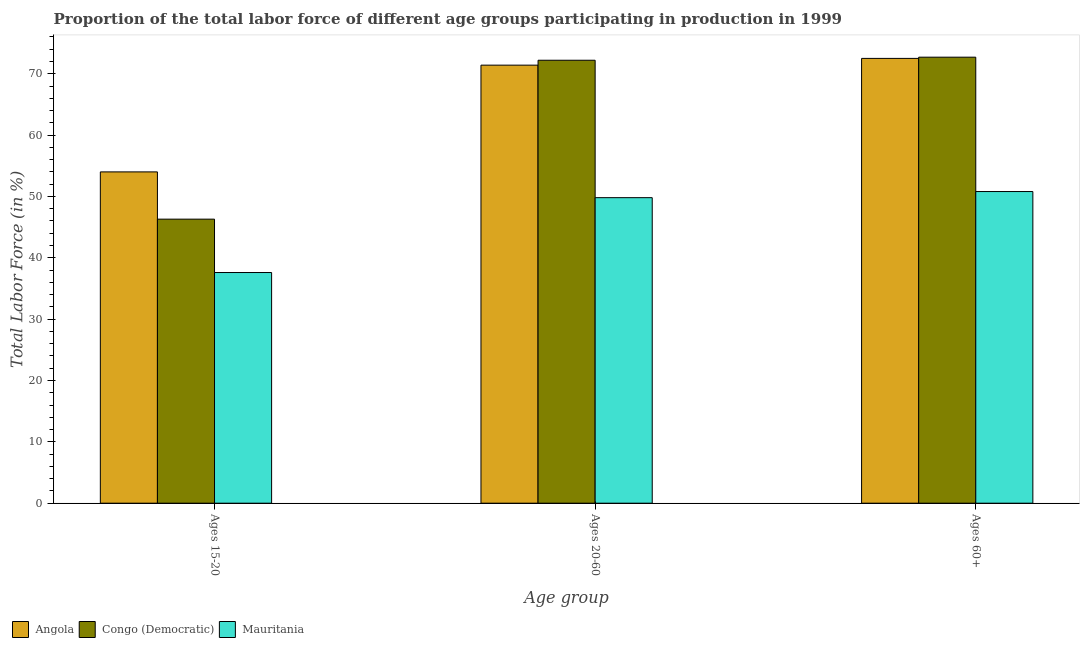How many groups of bars are there?
Ensure brevity in your answer.  3. What is the label of the 1st group of bars from the left?
Your answer should be very brief. Ages 15-20. What is the percentage of labor force within the age group 20-60 in Angola?
Offer a terse response. 71.4. Across all countries, what is the maximum percentage of labor force within the age group 20-60?
Your answer should be compact. 72.2. Across all countries, what is the minimum percentage of labor force within the age group 15-20?
Your answer should be compact. 37.6. In which country was the percentage of labor force within the age group 15-20 maximum?
Ensure brevity in your answer.  Angola. In which country was the percentage of labor force within the age group 15-20 minimum?
Keep it short and to the point. Mauritania. What is the total percentage of labor force above age 60 in the graph?
Your answer should be very brief. 196. What is the difference between the percentage of labor force within the age group 20-60 in Angola and that in Congo (Democratic)?
Make the answer very short. -0.8. What is the difference between the percentage of labor force above age 60 in Mauritania and the percentage of labor force within the age group 20-60 in Congo (Democratic)?
Ensure brevity in your answer.  -21.4. What is the average percentage of labor force within the age group 20-60 per country?
Your response must be concise. 64.47. What is the difference between the percentage of labor force within the age group 15-20 and percentage of labor force above age 60 in Angola?
Provide a succinct answer. -18.5. What is the ratio of the percentage of labor force within the age group 20-60 in Mauritania to that in Congo (Democratic)?
Provide a short and direct response. 0.69. Is the difference between the percentage of labor force within the age group 15-20 in Angola and Congo (Democratic) greater than the difference between the percentage of labor force above age 60 in Angola and Congo (Democratic)?
Offer a terse response. Yes. What is the difference between the highest and the second highest percentage of labor force within the age group 20-60?
Offer a very short reply. 0.8. What is the difference between the highest and the lowest percentage of labor force above age 60?
Provide a short and direct response. 21.9. What does the 2nd bar from the left in Ages 15-20 represents?
Provide a short and direct response. Congo (Democratic). What does the 2nd bar from the right in Ages 15-20 represents?
Ensure brevity in your answer.  Congo (Democratic). What is the difference between two consecutive major ticks on the Y-axis?
Your answer should be compact. 10. Are the values on the major ticks of Y-axis written in scientific E-notation?
Provide a short and direct response. No. Does the graph contain any zero values?
Provide a short and direct response. No. How are the legend labels stacked?
Your answer should be compact. Horizontal. What is the title of the graph?
Offer a very short reply. Proportion of the total labor force of different age groups participating in production in 1999. Does "American Samoa" appear as one of the legend labels in the graph?
Your answer should be very brief. No. What is the label or title of the X-axis?
Your response must be concise. Age group. What is the Total Labor Force (in %) in Congo (Democratic) in Ages 15-20?
Offer a terse response. 46.3. What is the Total Labor Force (in %) in Mauritania in Ages 15-20?
Provide a succinct answer. 37.6. What is the Total Labor Force (in %) of Angola in Ages 20-60?
Provide a succinct answer. 71.4. What is the Total Labor Force (in %) of Congo (Democratic) in Ages 20-60?
Provide a succinct answer. 72.2. What is the Total Labor Force (in %) in Mauritania in Ages 20-60?
Keep it short and to the point. 49.8. What is the Total Labor Force (in %) in Angola in Ages 60+?
Offer a very short reply. 72.5. What is the Total Labor Force (in %) of Congo (Democratic) in Ages 60+?
Give a very brief answer. 72.7. What is the Total Labor Force (in %) of Mauritania in Ages 60+?
Provide a short and direct response. 50.8. Across all Age group, what is the maximum Total Labor Force (in %) in Angola?
Your answer should be compact. 72.5. Across all Age group, what is the maximum Total Labor Force (in %) of Congo (Democratic)?
Your response must be concise. 72.7. Across all Age group, what is the maximum Total Labor Force (in %) of Mauritania?
Your answer should be very brief. 50.8. Across all Age group, what is the minimum Total Labor Force (in %) in Congo (Democratic)?
Provide a succinct answer. 46.3. Across all Age group, what is the minimum Total Labor Force (in %) of Mauritania?
Keep it short and to the point. 37.6. What is the total Total Labor Force (in %) in Angola in the graph?
Give a very brief answer. 197.9. What is the total Total Labor Force (in %) of Congo (Democratic) in the graph?
Provide a short and direct response. 191.2. What is the total Total Labor Force (in %) of Mauritania in the graph?
Provide a succinct answer. 138.2. What is the difference between the Total Labor Force (in %) in Angola in Ages 15-20 and that in Ages 20-60?
Keep it short and to the point. -17.4. What is the difference between the Total Labor Force (in %) of Congo (Democratic) in Ages 15-20 and that in Ages 20-60?
Provide a succinct answer. -25.9. What is the difference between the Total Labor Force (in %) in Mauritania in Ages 15-20 and that in Ages 20-60?
Keep it short and to the point. -12.2. What is the difference between the Total Labor Force (in %) in Angola in Ages 15-20 and that in Ages 60+?
Keep it short and to the point. -18.5. What is the difference between the Total Labor Force (in %) in Congo (Democratic) in Ages 15-20 and that in Ages 60+?
Keep it short and to the point. -26.4. What is the difference between the Total Labor Force (in %) of Mauritania in Ages 15-20 and that in Ages 60+?
Make the answer very short. -13.2. What is the difference between the Total Labor Force (in %) in Congo (Democratic) in Ages 20-60 and that in Ages 60+?
Offer a terse response. -0.5. What is the difference between the Total Labor Force (in %) in Angola in Ages 15-20 and the Total Labor Force (in %) in Congo (Democratic) in Ages 20-60?
Give a very brief answer. -18.2. What is the difference between the Total Labor Force (in %) in Angola in Ages 15-20 and the Total Labor Force (in %) in Mauritania in Ages 20-60?
Offer a terse response. 4.2. What is the difference between the Total Labor Force (in %) in Angola in Ages 15-20 and the Total Labor Force (in %) in Congo (Democratic) in Ages 60+?
Your response must be concise. -18.7. What is the difference between the Total Labor Force (in %) in Angola in Ages 20-60 and the Total Labor Force (in %) in Congo (Democratic) in Ages 60+?
Your answer should be compact. -1.3. What is the difference between the Total Labor Force (in %) of Angola in Ages 20-60 and the Total Labor Force (in %) of Mauritania in Ages 60+?
Provide a succinct answer. 20.6. What is the difference between the Total Labor Force (in %) of Congo (Democratic) in Ages 20-60 and the Total Labor Force (in %) of Mauritania in Ages 60+?
Your answer should be very brief. 21.4. What is the average Total Labor Force (in %) of Angola per Age group?
Your answer should be very brief. 65.97. What is the average Total Labor Force (in %) in Congo (Democratic) per Age group?
Offer a terse response. 63.73. What is the average Total Labor Force (in %) in Mauritania per Age group?
Provide a succinct answer. 46.07. What is the difference between the Total Labor Force (in %) in Angola and Total Labor Force (in %) in Mauritania in Ages 15-20?
Make the answer very short. 16.4. What is the difference between the Total Labor Force (in %) in Congo (Democratic) and Total Labor Force (in %) in Mauritania in Ages 15-20?
Your answer should be very brief. 8.7. What is the difference between the Total Labor Force (in %) in Angola and Total Labor Force (in %) in Mauritania in Ages 20-60?
Give a very brief answer. 21.6. What is the difference between the Total Labor Force (in %) of Congo (Democratic) and Total Labor Force (in %) of Mauritania in Ages 20-60?
Your response must be concise. 22.4. What is the difference between the Total Labor Force (in %) of Angola and Total Labor Force (in %) of Congo (Democratic) in Ages 60+?
Give a very brief answer. -0.2. What is the difference between the Total Labor Force (in %) of Angola and Total Labor Force (in %) of Mauritania in Ages 60+?
Provide a succinct answer. 21.7. What is the difference between the Total Labor Force (in %) of Congo (Democratic) and Total Labor Force (in %) of Mauritania in Ages 60+?
Offer a terse response. 21.9. What is the ratio of the Total Labor Force (in %) of Angola in Ages 15-20 to that in Ages 20-60?
Your response must be concise. 0.76. What is the ratio of the Total Labor Force (in %) in Congo (Democratic) in Ages 15-20 to that in Ages 20-60?
Your answer should be very brief. 0.64. What is the ratio of the Total Labor Force (in %) in Mauritania in Ages 15-20 to that in Ages 20-60?
Your response must be concise. 0.76. What is the ratio of the Total Labor Force (in %) of Angola in Ages 15-20 to that in Ages 60+?
Give a very brief answer. 0.74. What is the ratio of the Total Labor Force (in %) in Congo (Democratic) in Ages 15-20 to that in Ages 60+?
Your response must be concise. 0.64. What is the ratio of the Total Labor Force (in %) of Mauritania in Ages 15-20 to that in Ages 60+?
Give a very brief answer. 0.74. What is the ratio of the Total Labor Force (in %) of Mauritania in Ages 20-60 to that in Ages 60+?
Ensure brevity in your answer.  0.98. What is the difference between the highest and the second highest Total Labor Force (in %) of Angola?
Your response must be concise. 1.1. What is the difference between the highest and the second highest Total Labor Force (in %) in Congo (Democratic)?
Give a very brief answer. 0.5. What is the difference between the highest and the second highest Total Labor Force (in %) of Mauritania?
Keep it short and to the point. 1. What is the difference between the highest and the lowest Total Labor Force (in %) in Congo (Democratic)?
Provide a succinct answer. 26.4. What is the difference between the highest and the lowest Total Labor Force (in %) in Mauritania?
Keep it short and to the point. 13.2. 